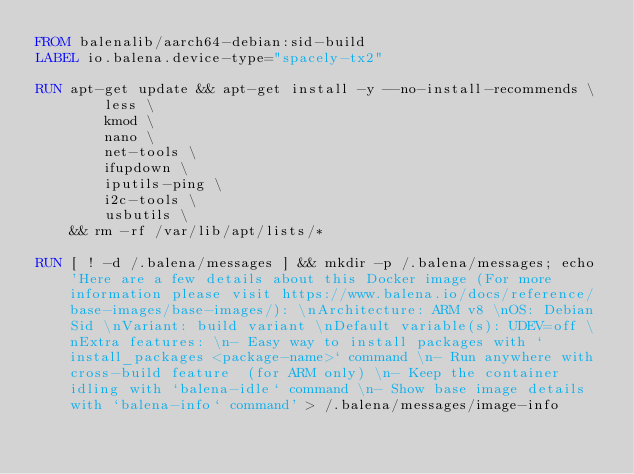<code> <loc_0><loc_0><loc_500><loc_500><_Dockerfile_>FROM balenalib/aarch64-debian:sid-build
LABEL io.balena.device-type="spacely-tx2"

RUN apt-get update && apt-get install -y --no-install-recommends \
		less \
		kmod \
		nano \
		net-tools \
		ifupdown \
		iputils-ping \
		i2c-tools \
		usbutils \
	&& rm -rf /var/lib/apt/lists/*

RUN [ ! -d /.balena/messages ] && mkdir -p /.balena/messages; echo 'Here are a few details about this Docker image (For more information please visit https://www.balena.io/docs/reference/base-images/base-images/): \nArchitecture: ARM v8 \nOS: Debian Sid \nVariant: build variant \nDefault variable(s): UDEV=off \nExtra features: \n- Easy way to install packages with `install_packages <package-name>` command \n- Run anywhere with cross-build feature  (for ARM only) \n- Keep the container idling with `balena-idle` command \n- Show base image details with `balena-info` command' > /.balena/messages/image-info</code> 